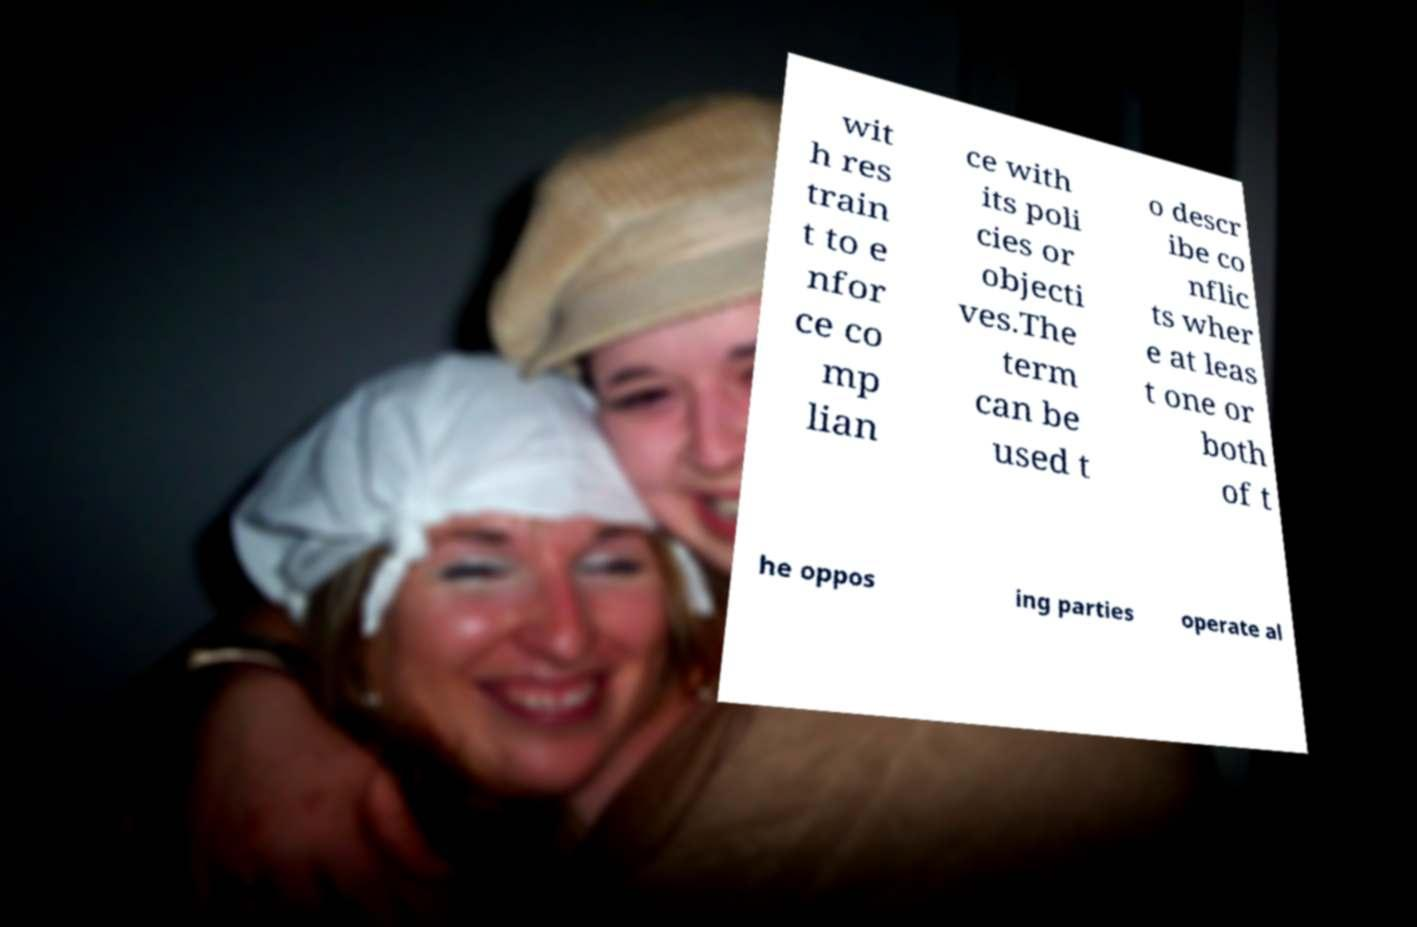What messages or text are displayed in this image? I need them in a readable, typed format. wit h res train t to e nfor ce co mp lian ce with its poli cies or objecti ves.The term can be used t o descr ibe co nflic ts wher e at leas t one or both of t he oppos ing parties operate al 